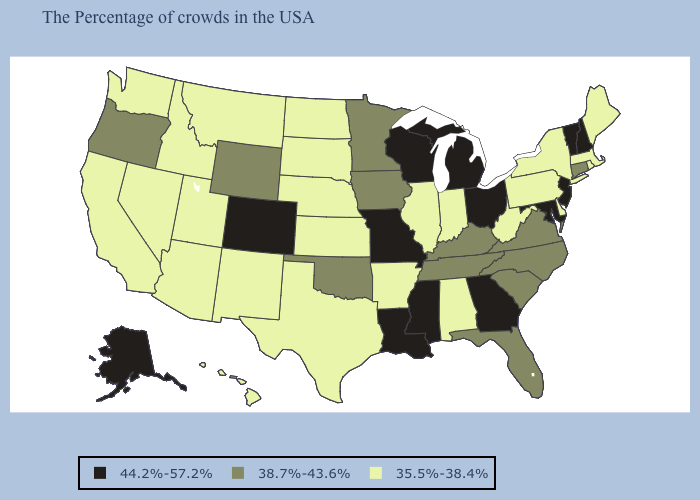What is the highest value in the Northeast ?
Keep it brief. 44.2%-57.2%. What is the highest value in the USA?
Be succinct. 44.2%-57.2%. Name the states that have a value in the range 35.5%-38.4%?
Concise answer only. Maine, Massachusetts, Rhode Island, New York, Delaware, Pennsylvania, West Virginia, Indiana, Alabama, Illinois, Arkansas, Kansas, Nebraska, Texas, South Dakota, North Dakota, New Mexico, Utah, Montana, Arizona, Idaho, Nevada, California, Washington, Hawaii. Does the first symbol in the legend represent the smallest category?
Be succinct. No. Does Oregon have the highest value in the West?
Short answer required. No. What is the value of Massachusetts?
Short answer required. 35.5%-38.4%. What is the lowest value in the West?
Give a very brief answer. 35.5%-38.4%. What is the value of Virginia?
Concise answer only. 38.7%-43.6%. Does the map have missing data?
Answer briefly. No. Does the map have missing data?
Write a very short answer. No. Among the states that border Florida , does Alabama have the lowest value?
Keep it brief. Yes. Does Kentucky have a lower value than Idaho?
Concise answer only. No. What is the value of Georgia?
Be succinct. 44.2%-57.2%. Which states hav the highest value in the South?
Keep it brief. Maryland, Georgia, Mississippi, Louisiana. What is the value of Colorado?
Be succinct. 44.2%-57.2%. 